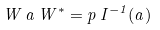<formula> <loc_0><loc_0><loc_500><loc_500>W \, a \, W ^ { * } = p \, I ^ { - 1 } ( a )</formula> 